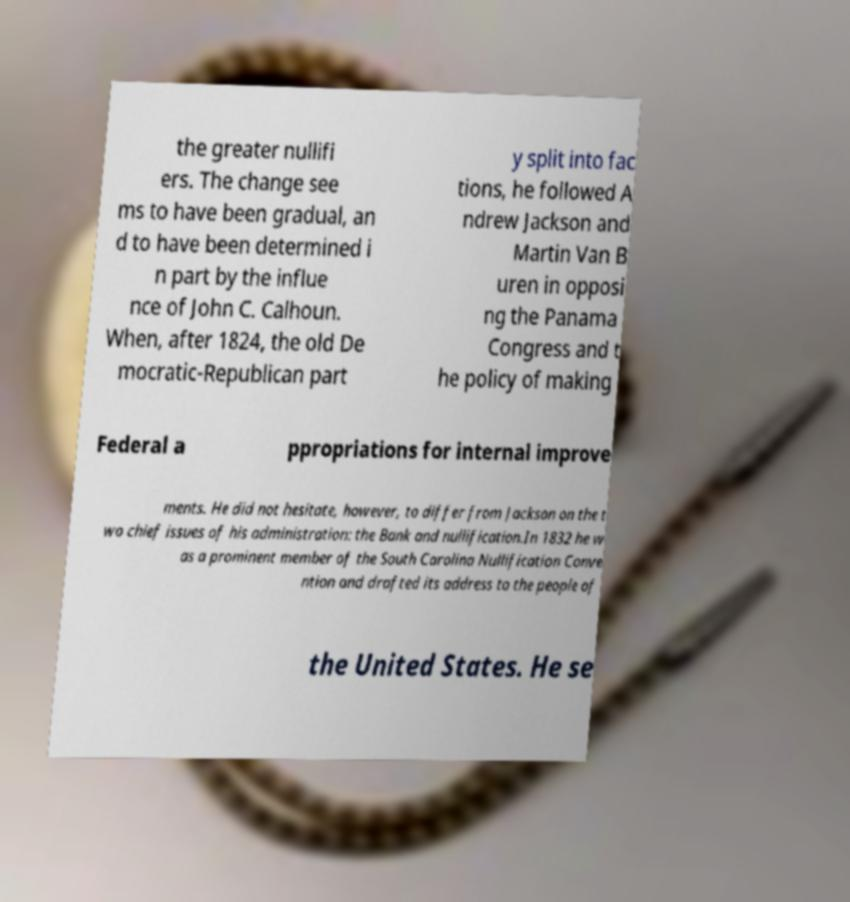For documentation purposes, I need the text within this image transcribed. Could you provide that? the greater nullifi ers. The change see ms to have been gradual, an d to have been determined i n part by the influe nce of John C. Calhoun. When, after 1824, the old De mocratic-Republican part y split into fac tions, he followed A ndrew Jackson and Martin Van B uren in opposi ng the Panama Congress and t he policy of making Federal a ppropriations for internal improve ments. He did not hesitate, however, to differ from Jackson on the t wo chief issues of his administration: the Bank and nullification.In 1832 he w as a prominent member of the South Carolina Nullification Conve ntion and drafted its address to the people of the United States. He se 